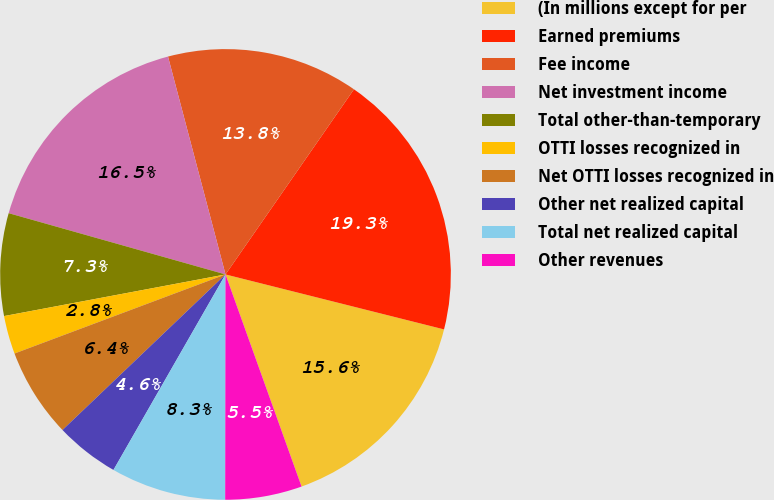Convert chart to OTSL. <chart><loc_0><loc_0><loc_500><loc_500><pie_chart><fcel>(In millions except for per<fcel>Earned premiums<fcel>Fee income<fcel>Net investment income<fcel>Total other-than-temporary<fcel>OTTI losses recognized in<fcel>Net OTTI losses recognized in<fcel>Other net realized capital<fcel>Total net realized capital<fcel>Other revenues<nl><fcel>15.6%<fcel>19.27%<fcel>13.76%<fcel>16.51%<fcel>7.34%<fcel>2.75%<fcel>6.42%<fcel>4.59%<fcel>8.26%<fcel>5.5%<nl></chart> 